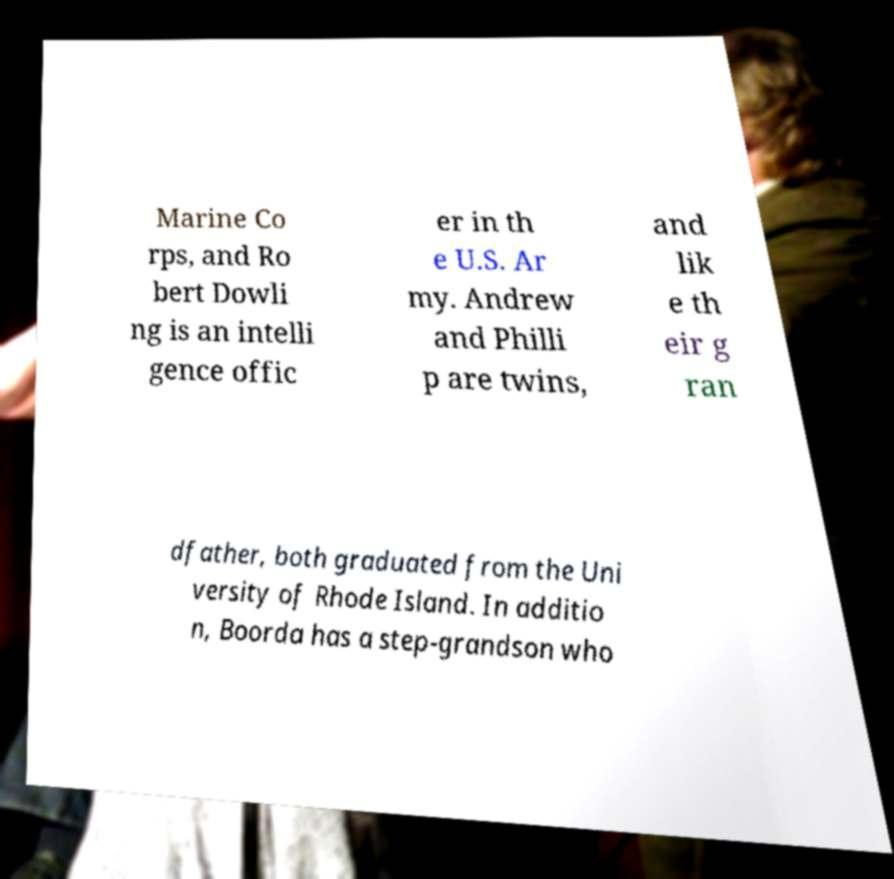Please read and relay the text visible in this image. What does it say? Marine Co rps, and Ro bert Dowli ng is an intelli gence offic er in th e U.S. Ar my. Andrew and Philli p are twins, and lik e th eir g ran dfather, both graduated from the Uni versity of Rhode Island. In additio n, Boorda has a step-grandson who 